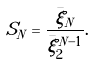<formula> <loc_0><loc_0><loc_500><loc_500>S _ { N } = \frac { \bar { \xi } _ { N } } { \bar { \xi } _ { 2 } ^ { N - 1 } } .</formula> 